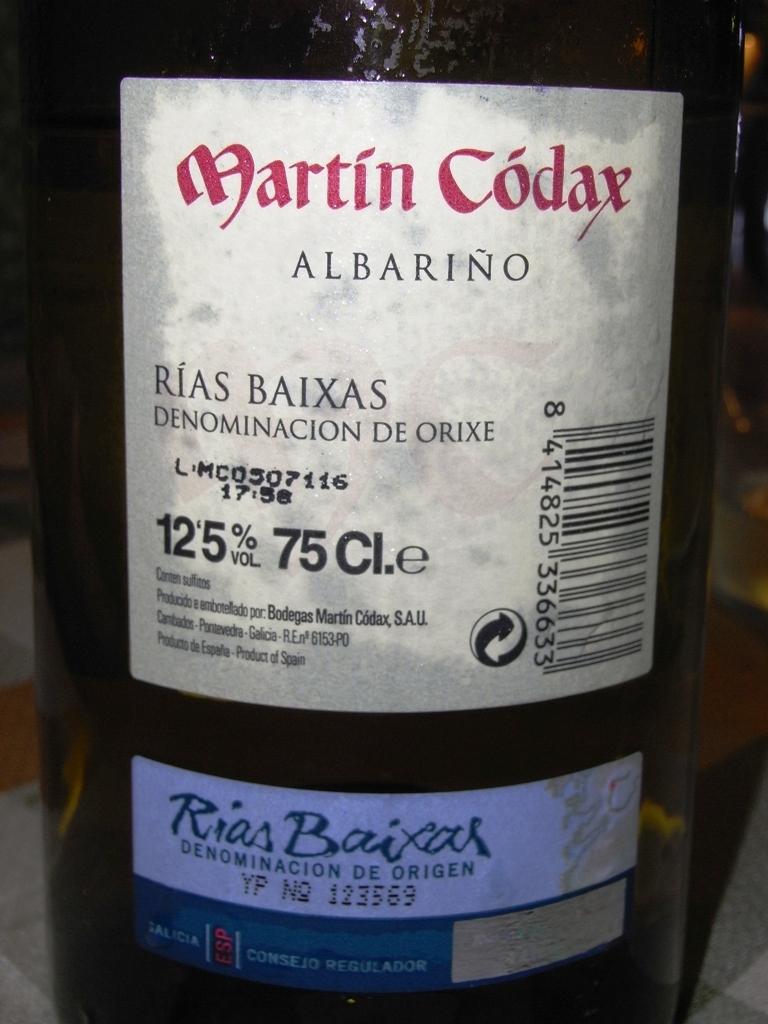How many cl is this drink?
Your answer should be very brief. 75. What is the brand of this?
Keep it short and to the point. Martin codax. 